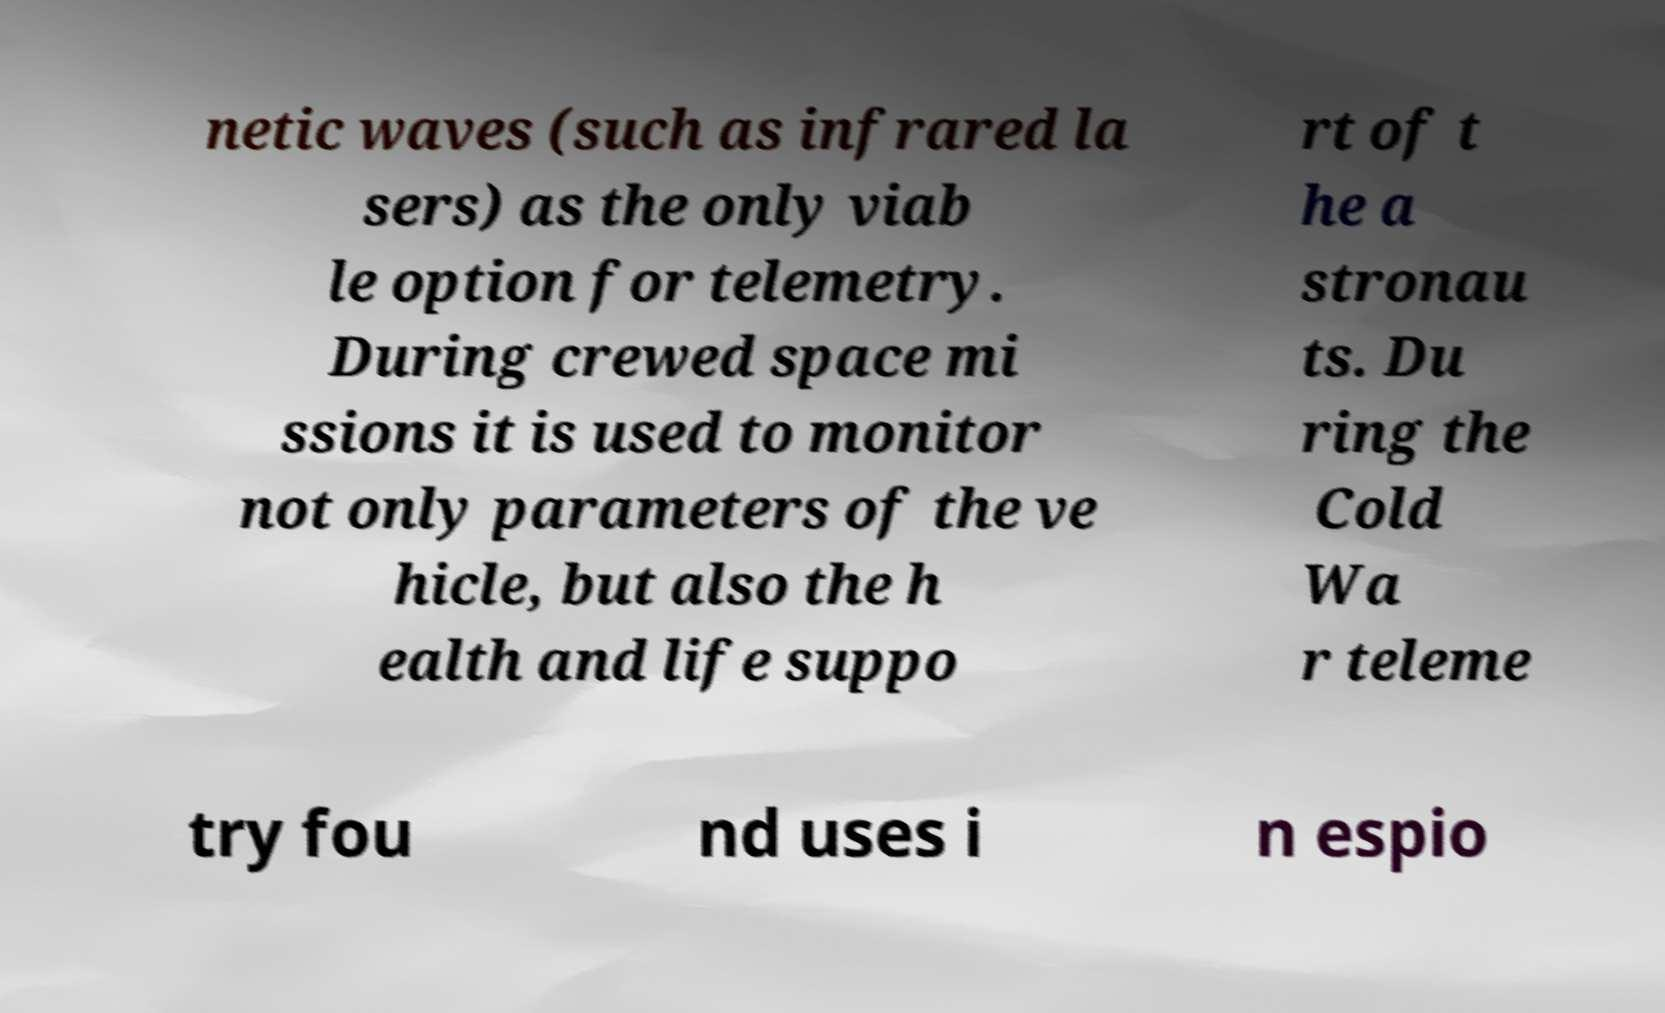Can you accurately transcribe the text from the provided image for me? netic waves (such as infrared la sers) as the only viab le option for telemetry. During crewed space mi ssions it is used to monitor not only parameters of the ve hicle, but also the h ealth and life suppo rt of t he a stronau ts. Du ring the Cold Wa r teleme try fou nd uses i n espio 